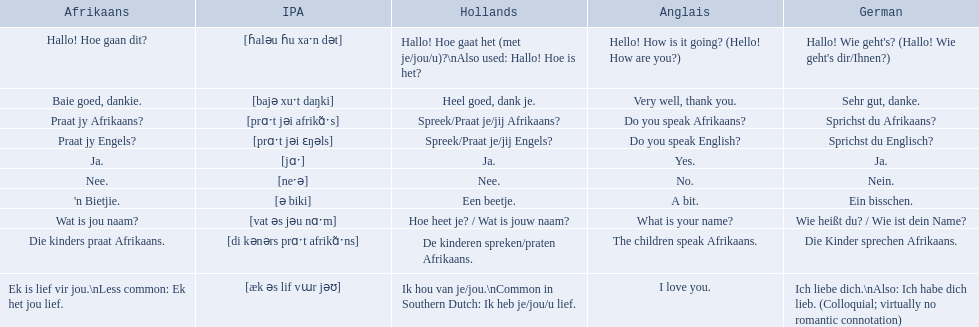Parse the full table in json format. {'header': ['Afrikaans', 'IPA', 'Hollands', 'Anglais', 'German'], 'rows': [['Hallo! Hoe gaan dit?', '[ɦaləu ɦu xaˑn dət]', 'Hallo! Hoe gaat het (met je/jou/u)?\\nAlso used: Hallo! Hoe is het?', 'Hello! How is it going? (Hello! How are you?)', "Hallo! Wie geht's? (Hallo! Wie geht's dir/Ihnen?)"], ['Baie goed, dankie.', '[bajə xuˑt daŋki]', 'Heel goed, dank je.', 'Very well, thank you.', 'Sehr gut, danke.'], ['Praat jy Afrikaans?', '[prɑˑt jəi afrikɑ̃ˑs]', 'Spreek/Praat je/jij Afrikaans?', 'Do you speak Afrikaans?', 'Sprichst du Afrikaans?'], ['Praat jy Engels?', '[prɑˑt jəi ɛŋəls]', 'Spreek/Praat je/jij Engels?', 'Do you speak English?', 'Sprichst du Englisch?'], ['Ja.', '[jɑˑ]', 'Ja.', 'Yes.', 'Ja.'], ['Nee.', '[neˑə]', 'Nee.', 'No.', 'Nein.'], ["'n Bietjie.", '[ə biki]', 'Een beetje.', 'A bit.', 'Ein bisschen.'], ['Wat is jou naam?', '[vat əs jəu nɑˑm]', 'Hoe heet je? / Wat is jouw naam?', 'What is your name?', 'Wie heißt du? / Wie ist dein Name?'], ['Die kinders praat Afrikaans.', '[di kənərs prɑˑt afrikɑ̃ˑns]', 'De kinderen spreken/praten Afrikaans.', 'The children speak Afrikaans.', 'Die Kinder sprechen Afrikaans.'], ['Ek is lief vir jou.\\nLess common: Ek het jou lief.', '[æk əs lif vɯr jəʊ]', 'Ik hou van je/jou.\\nCommon in Southern Dutch: Ik heb je/jou/u lief.', 'I love you.', 'Ich liebe dich.\\nAlso: Ich habe dich lieb. (Colloquial; virtually no romantic connotation)']]} In german how do you say do you speak afrikaans? Sprichst du Afrikaans?. How do you say it in afrikaans? Praat jy Afrikaans?. 